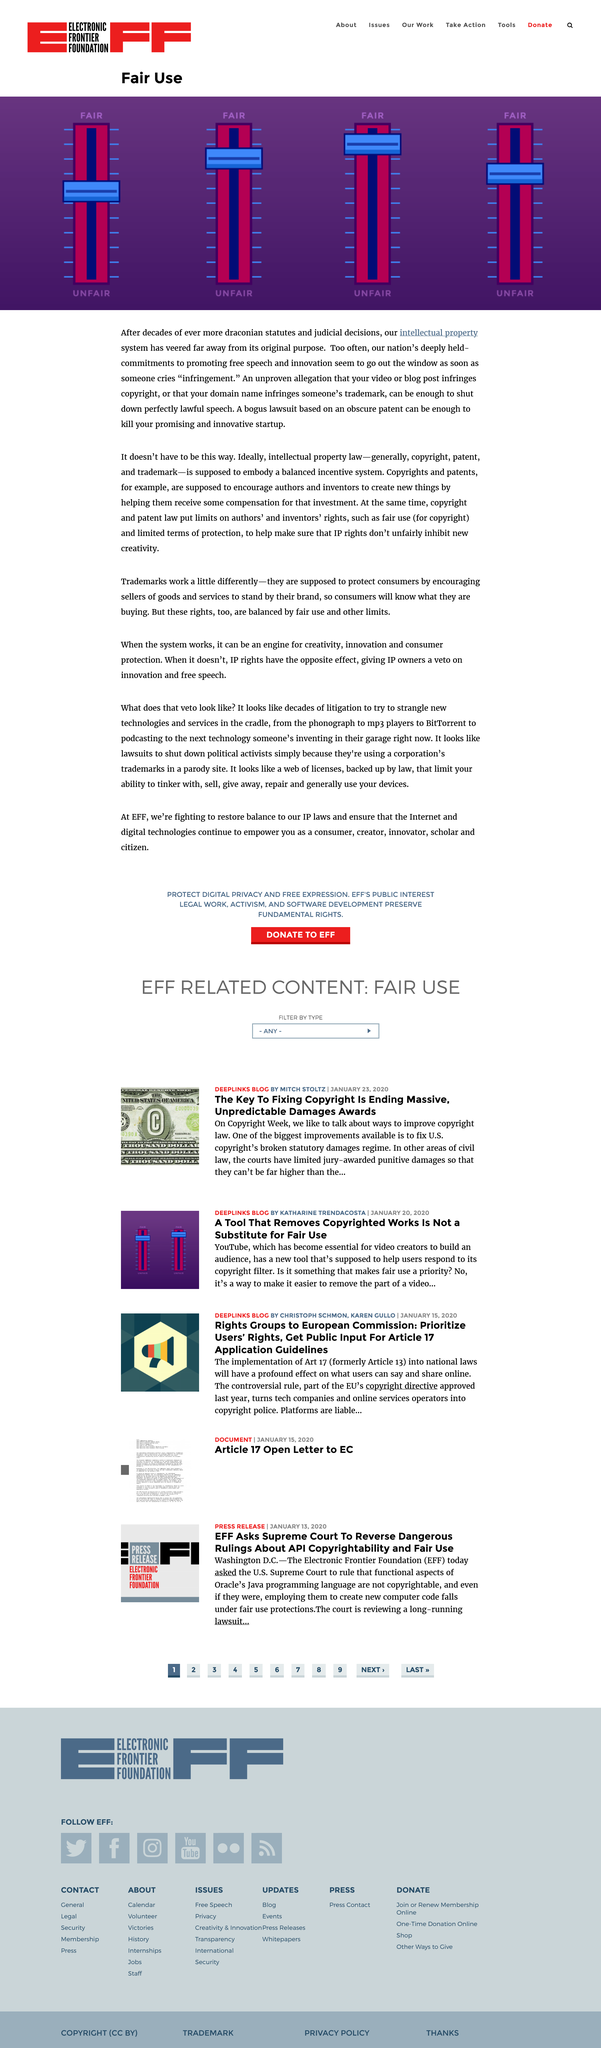Indicate a few pertinent items in this graphic. In the article "Fair Use," 3 dials are pictured. This page is about fair use, and it clarifies the purpose of the topic. The title of this page is "Fair Use. 